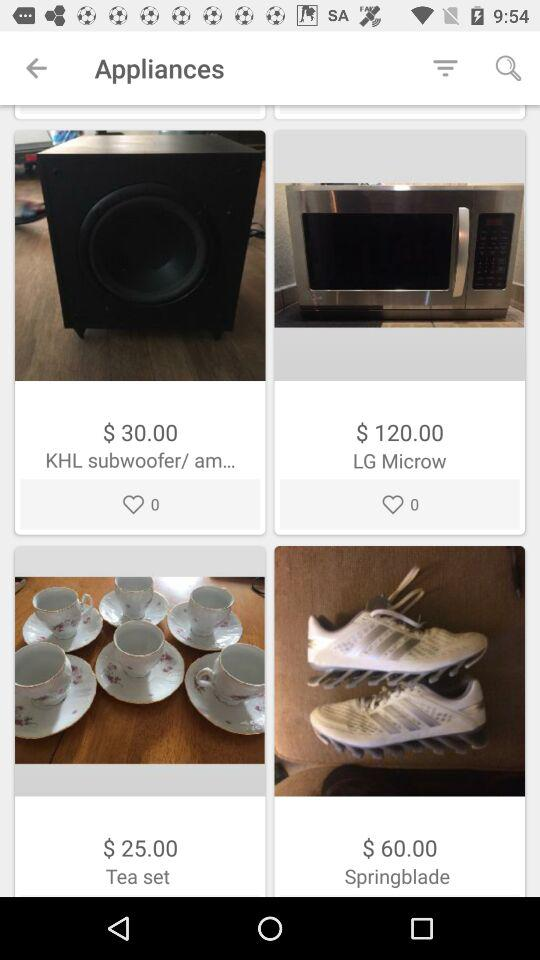What is the number of likes for the KHL subwoofer? The number of likes is 0. 